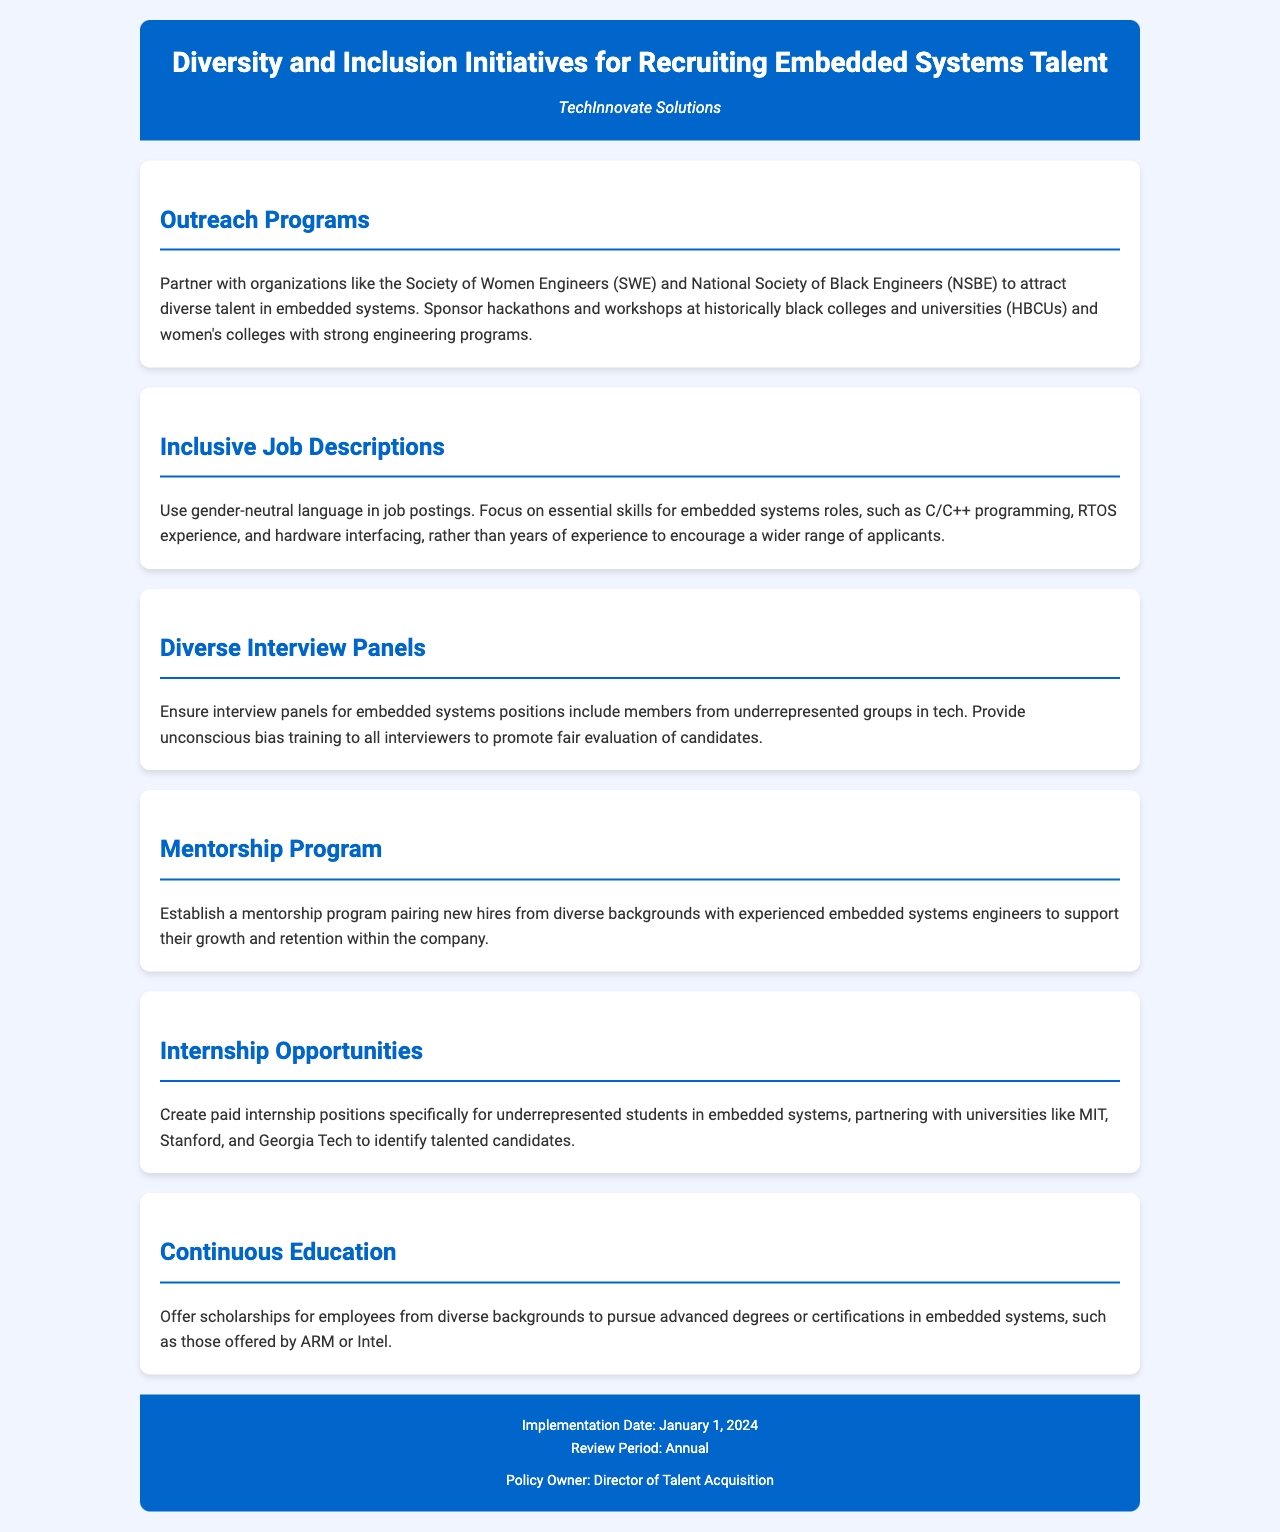What organizations does TechInnovate Solutions partner with? The document mentions partnerships with the Society of Women Engineers (SWE) and the National Society of Black Engineers (NSBE) for outreach programs.
Answer: Society of Women Engineers, National Society of Black Engineers What kind of language is recommended for job descriptions? The document suggests using gender-neutral language in job postings for inclusivity.
Answer: Gender-neutral language What training is provided to interviewers? It states that unconscious bias training is provided to promote fair evaluation of candidates in the interview process.
Answer: Unconscious bias training What is the implementation date of the policy? The document specifies January 1, 2024, as the implementation date for the diversity initiatives.
Answer: January 1, 2024 What is the purpose of the mentorship program? The mentorship program is intended to support the growth and retention of new hires from diverse backgrounds.
Answer: Support growth and retention Which universities are mentioned for creating internship opportunities? The document lists MIT, Stanford, and Georgia Tech as universities to partner with for internship recruitment.
Answer: MIT, Stanford, Georgia Tech How often will the policy be reviewed? According to the document, the policy will be reviewed annually.
Answer: Annual What type of candidates are targeted for paid internships? The document indicates that paid internship positions are specifically for underrepresented students in embedded systems.
Answer: Underrepresented students 